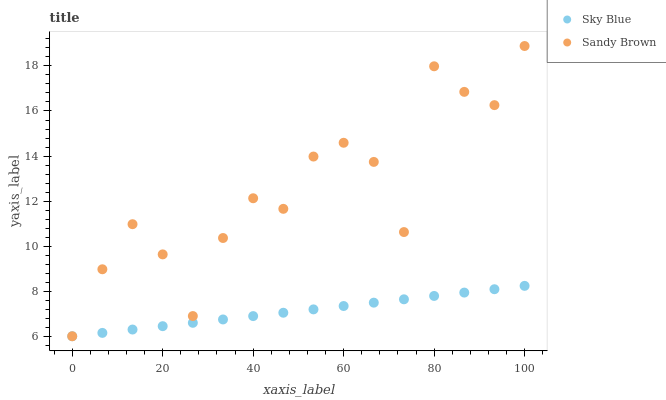Does Sky Blue have the minimum area under the curve?
Answer yes or no. Yes. Does Sandy Brown have the maximum area under the curve?
Answer yes or no. Yes. Does Sandy Brown have the minimum area under the curve?
Answer yes or no. No. Is Sky Blue the smoothest?
Answer yes or no. Yes. Is Sandy Brown the roughest?
Answer yes or no. Yes. Is Sandy Brown the smoothest?
Answer yes or no. No. Does Sky Blue have the lowest value?
Answer yes or no. Yes. Does Sandy Brown have the highest value?
Answer yes or no. Yes. Does Sky Blue intersect Sandy Brown?
Answer yes or no. Yes. Is Sky Blue less than Sandy Brown?
Answer yes or no. No. Is Sky Blue greater than Sandy Brown?
Answer yes or no. No. 